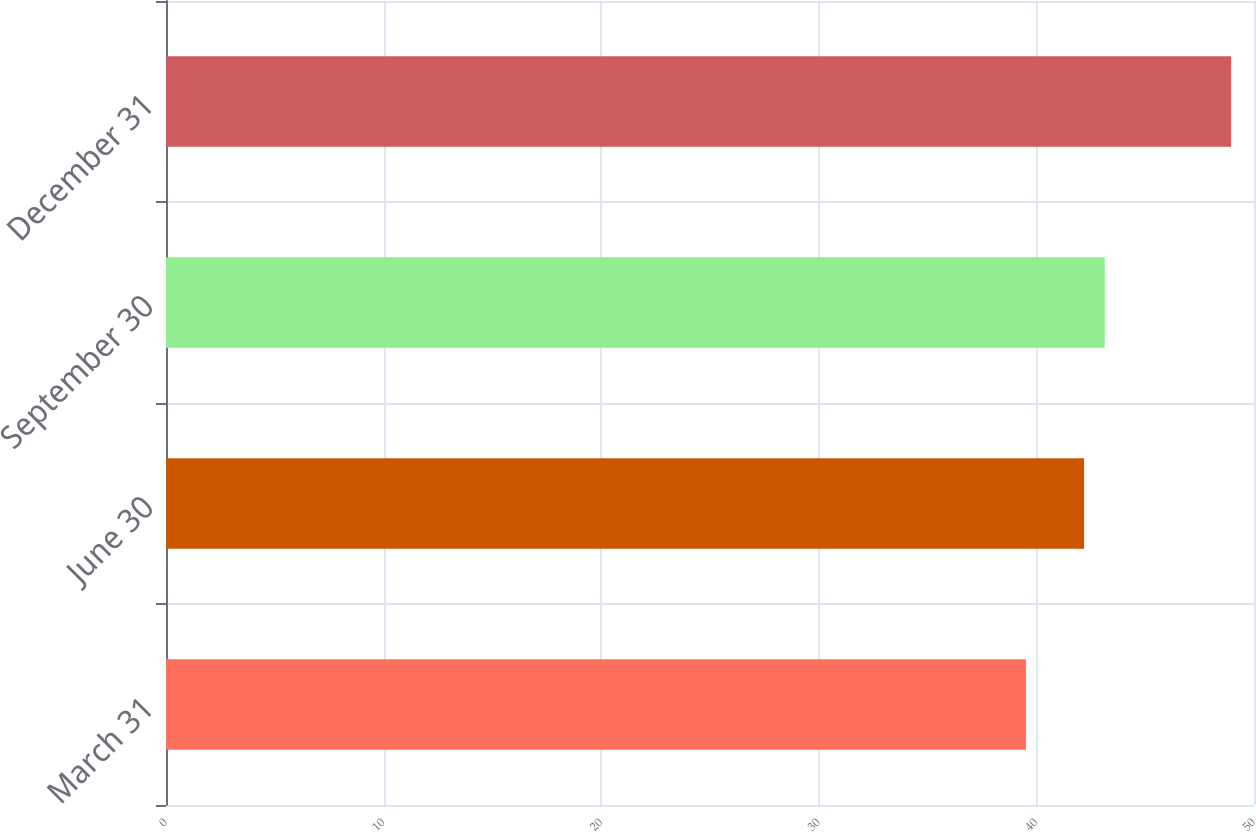Convert chart to OTSL. <chart><loc_0><loc_0><loc_500><loc_500><bar_chart><fcel>March 31<fcel>June 30<fcel>September 30<fcel>December 31<nl><fcel>39.52<fcel>42.19<fcel>43.14<fcel>48.95<nl></chart> 